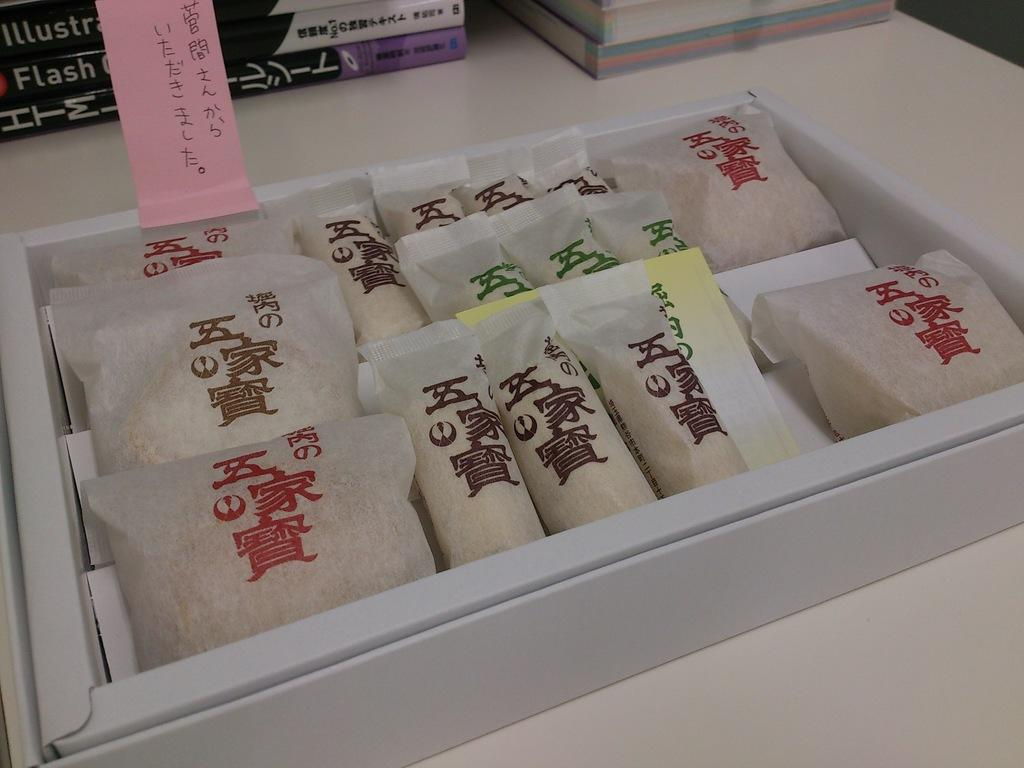What is inside the box that is visible in the image? There are packets inside the box in the image. What other items can be seen in the image besides the box? There are books in the image. Where are the box and books located in the image? The box and books are placed on a platform. Can you tell me how the cook is preparing the packets in the image? There is no cook or preparation of packets visible in the image; it only shows a box with packets and books on a platform. 